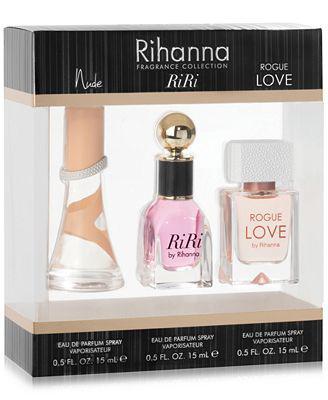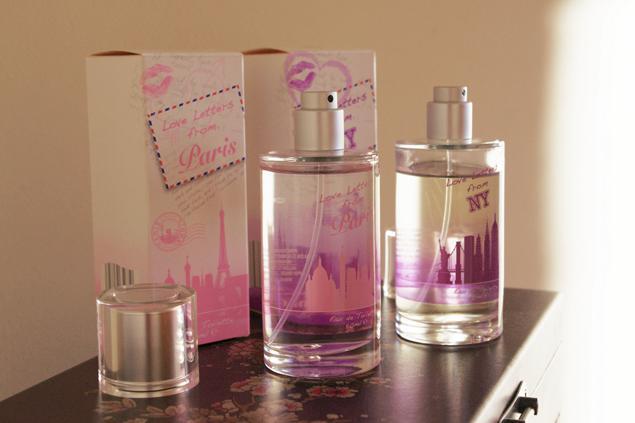The first image is the image on the left, the second image is the image on the right. For the images shown, is this caption "there are three or less boxes total" true? Answer yes or no. Yes. The first image is the image on the left, the second image is the image on the right. Considering the images on both sides, is "One box contains multiple items." valid? Answer yes or no. Yes. 